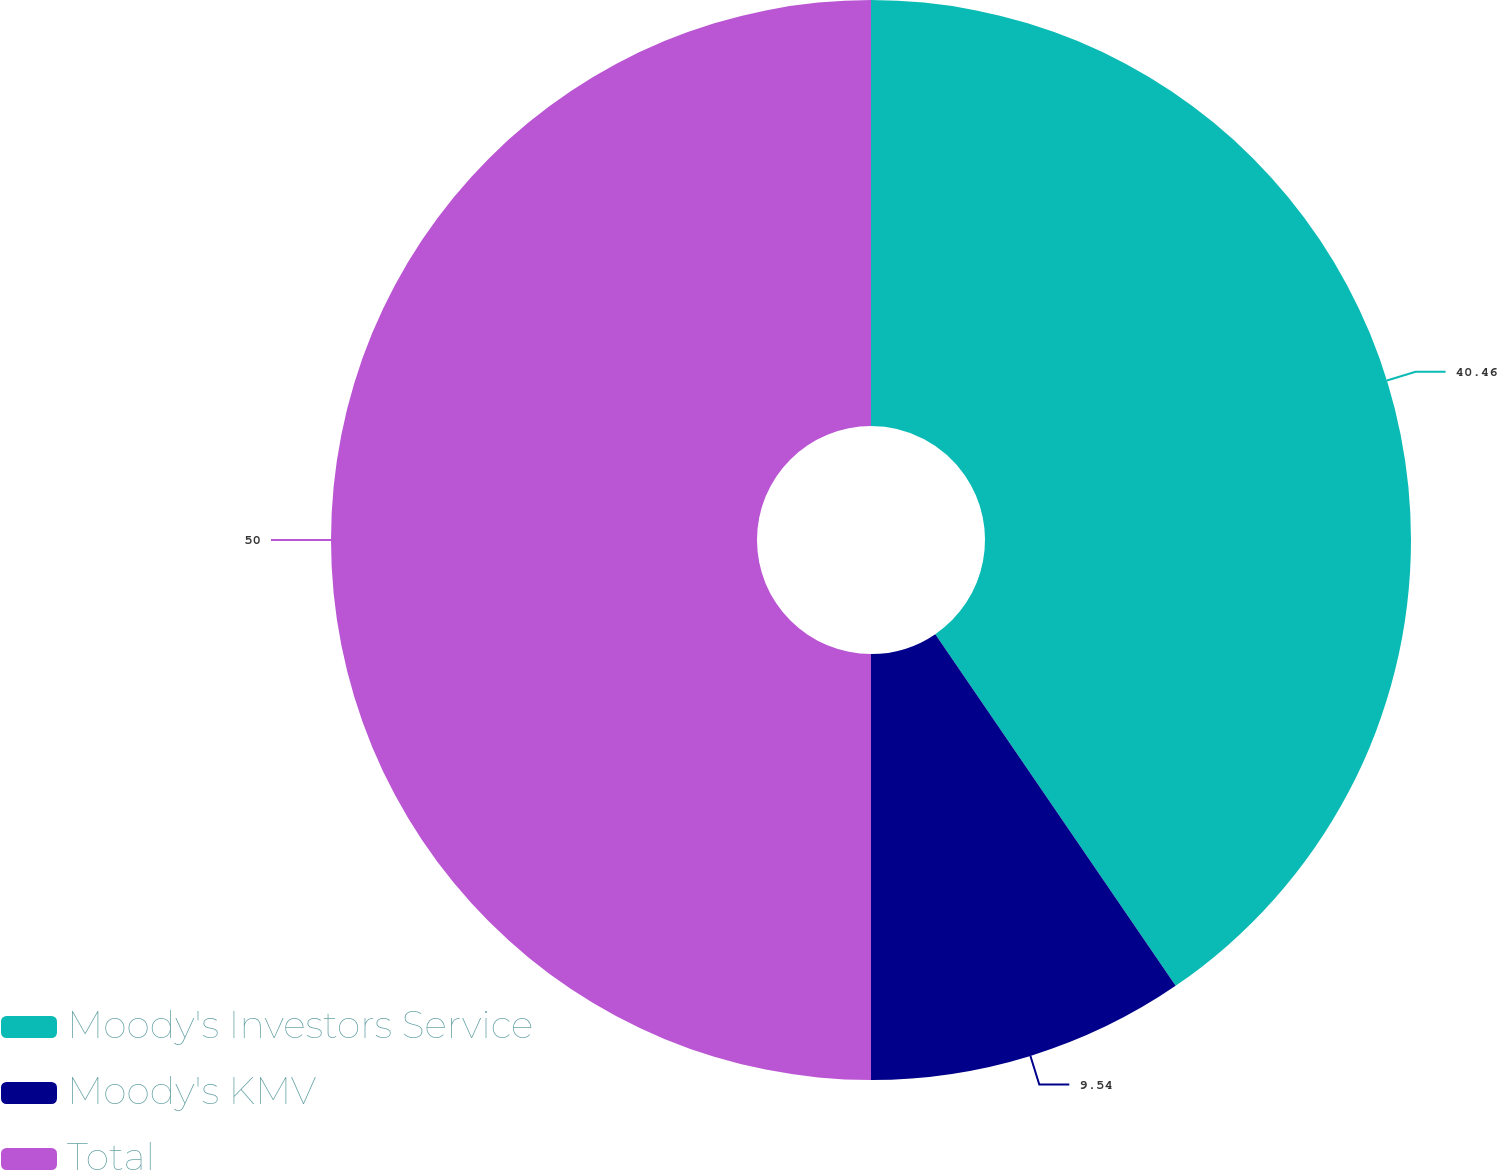Convert chart to OTSL. <chart><loc_0><loc_0><loc_500><loc_500><pie_chart><fcel>Moody's Investors Service<fcel>Moody's KMV<fcel>Total<nl><fcel>40.46%<fcel>9.54%<fcel>50.0%<nl></chart> 